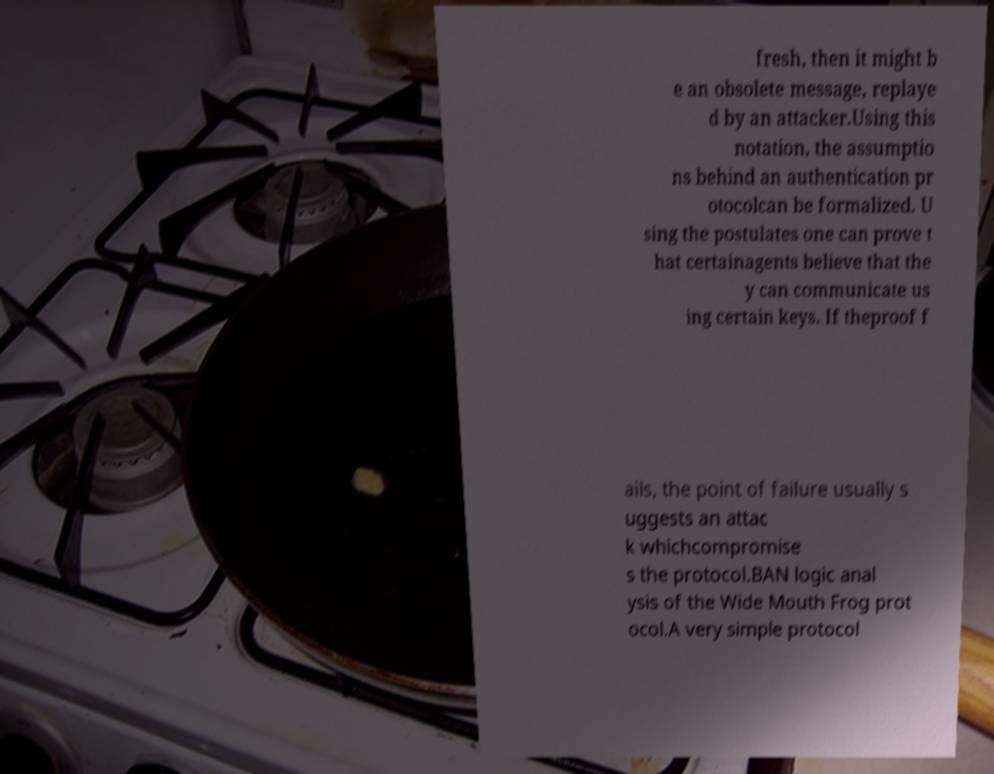Can you read and provide the text displayed in the image?This photo seems to have some interesting text. Can you extract and type it out for me? fresh, then it might b e an obsolete message, replaye d by an attacker.Using this notation, the assumptio ns behind an authentication pr otocolcan be formalized. U sing the postulates one can prove t hat certainagents believe that the y can communicate us ing certain keys. If theproof f ails, the point of failure usually s uggests an attac k whichcompromise s the protocol.BAN logic anal ysis of the Wide Mouth Frog prot ocol.A very simple protocol 